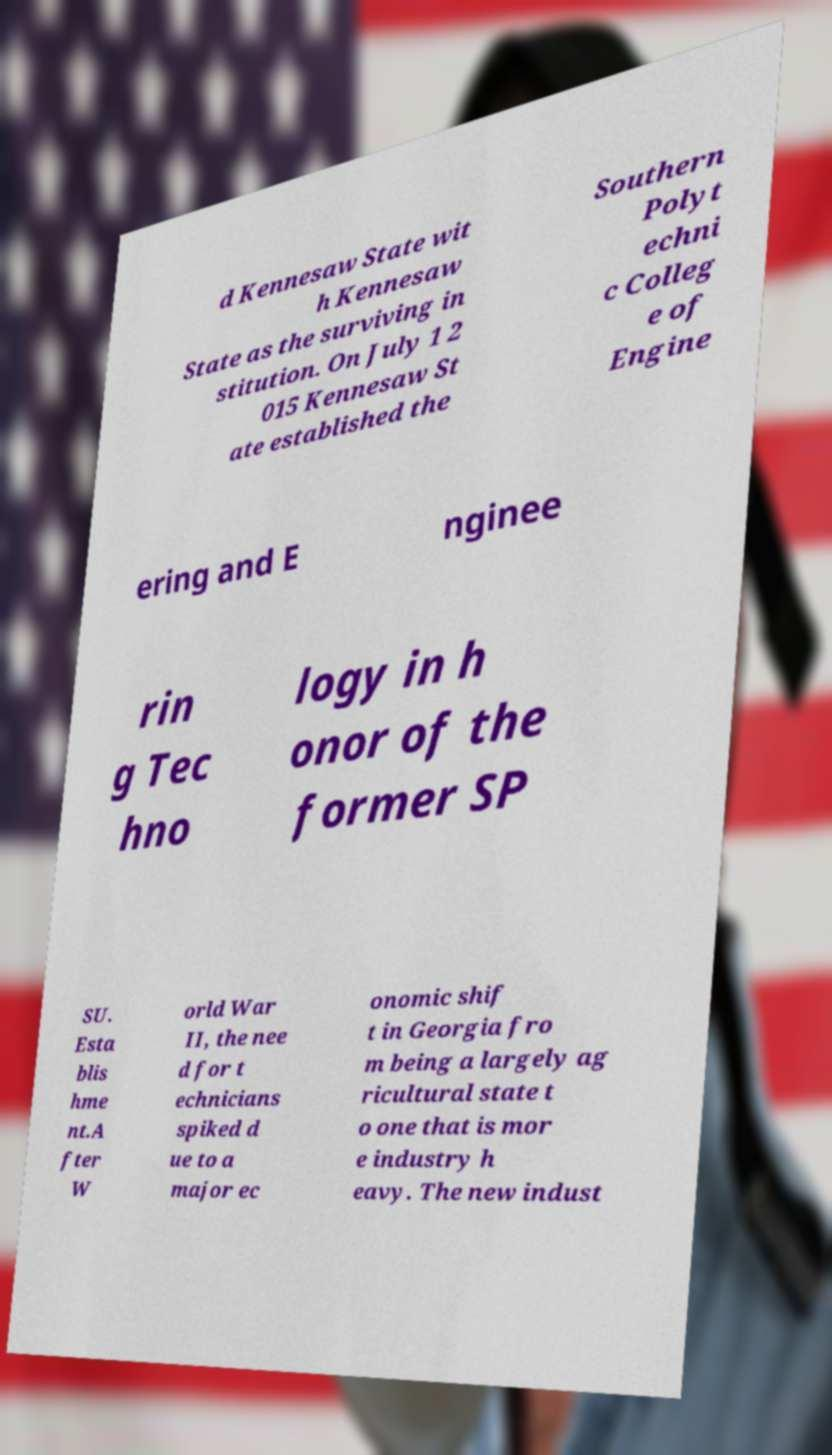Could you extract and type out the text from this image? d Kennesaw State wit h Kennesaw State as the surviving in stitution. On July 1 2 015 Kennesaw St ate established the Southern Polyt echni c Colleg e of Engine ering and E nginee rin g Tec hno logy in h onor of the former SP SU. Esta blis hme nt.A fter W orld War II, the nee d for t echnicians spiked d ue to a major ec onomic shif t in Georgia fro m being a largely ag ricultural state t o one that is mor e industry h eavy. The new indust 